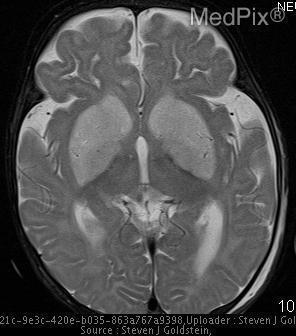Is there swelling around the lesion?
Quick response, please. No. Is it possible to see the cerebellum?
Be succinct. No. 